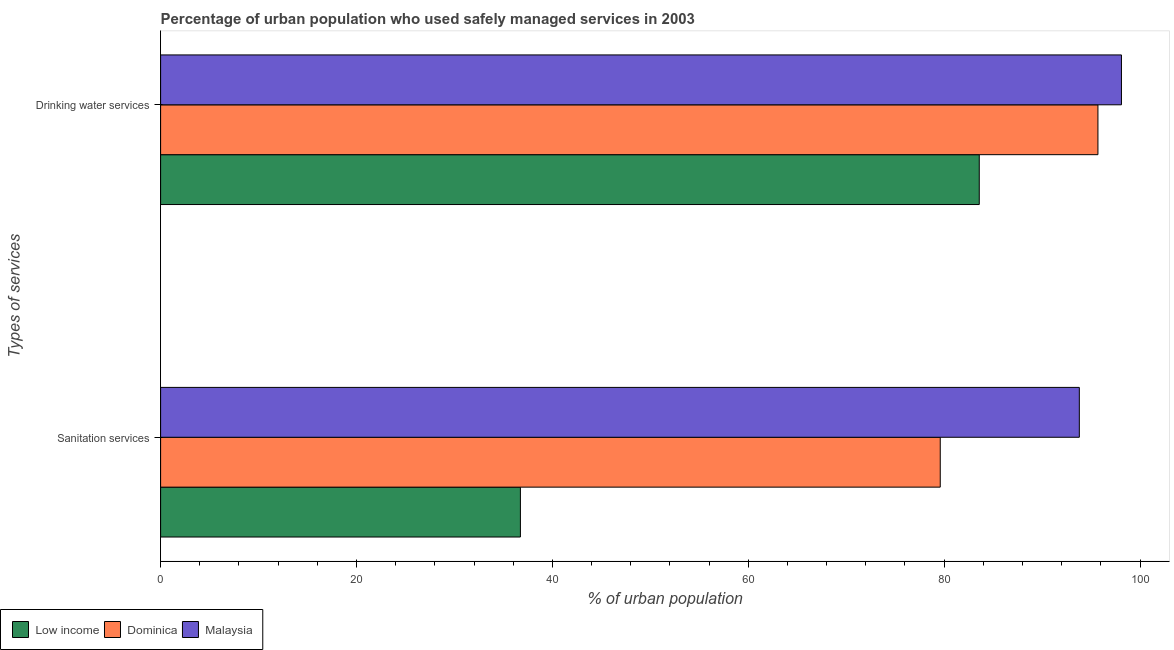How many different coloured bars are there?
Ensure brevity in your answer.  3. How many groups of bars are there?
Your answer should be very brief. 2. How many bars are there on the 2nd tick from the top?
Your response must be concise. 3. How many bars are there on the 1st tick from the bottom?
Provide a short and direct response. 3. What is the label of the 1st group of bars from the top?
Provide a short and direct response. Drinking water services. What is the percentage of urban population who used sanitation services in Malaysia?
Keep it short and to the point. 93.8. Across all countries, what is the maximum percentage of urban population who used drinking water services?
Give a very brief answer. 98.1. Across all countries, what is the minimum percentage of urban population who used drinking water services?
Provide a succinct answer. 83.58. In which country was the percentage of urban population who used sanitation services maximum?
Keep it short and to the point. Malaysia. In which country was the percentage of urban population who used sanitation services minimum?
Your answer should be very brief. Low income. What is the total percentage of urban population who used sanitation services in the graph?
Your response must be concise. 210.13. What is the difference between the percentage of urban population who used drinking water services in Low income and that in Malaysia?
Provide a short and direct response. -14.52. What is the difference between the percentage of urban population who used drinking water services in Low income and the percentage of urban population who used sanitation services in Malaysia?
Provide a short and direct response. -10.22. What is the average percentage of urban population who used sanitation services per country?
Ensure brevity in your answer.  70.04. What is the difference between the percentage of urban population who used sanitation services and percentage of urban population who used drinking water services in Low income?
Offer a very short reply. -46.85. In how many countries, is the percentage of urban population who used sanitation services greater than 48 %?
Offer a terse response. 2. What is the ratio of the percentage of urban population who used drinking water services in Malaysia to that in Low income?
Offer a terse response. 1.17. Is the percentage of urban population who used drinking water services in Low income less than that in Dominica?
Your answer should be very brief. Yes. What does the 3rd bar from the top in Drinking water services represents?
Provide a short and direct response. Low income. What does the 3rd bar from the bottom in Drinking water services represents?
Your response must be concise. Malaysia. Are all the bars in the graph horizontal?
Ensure brevity in your answer.  Yes. How many countries are there in the graph?
Your answer should be very brief. 3. What is the difference between two consecutive major ticks on the X-axis?
Your answer should be very brief. 20. How many legend labels are there?
Give a very brief answer. 3. What is the title of the graph?
Provide a succinct answer. Percentage of urban population who used safely managed services in 2003. Does "Guyana" appear as one of the legend labels in the graph?
Your answer should be very brief. No. What is the label or title of the X-axis?
Offer a very short reply. % of urban population. What is the label or title of the Y-axis?
Keep it short and to the point. Types of services. What is the % of urban population in Low income in Sanitation services?
Offer a very short reply. 36.73. What is the % of urban population of Dominica in Sanitation services?
Offer a very short reply. 79.6. What is the % of urban population of Malaysia in Sanitation services?
Offer a terse response. 93.8. What is the % of urban population in Low income in Drinking water services?
Give a very brief answer. 83.58. What is the % of urban population of Dominica in Drinking water services?
Provide a short and direct response. 95.7. What is the % of urban population in Malaysia in Drinking water services?
Provide a short and direct response. 98.1. Across all Types of services, what is the maximum % of urban population of Low income?
Your answer should be very brief. 83.58. Across all Types of services, what is the maximum % of urban population in Dominica?
Make the answer very short. 95.7. Across all Types of services, what is the maximum % of urban population of Malaysia?
Provide a succinct answer. 98.1. Across all Types of services, what is the minimum % of urban population of Low income?
Provide a short and direct response. 36.73. Across all Types of services, what is the minimum % of urban population of Dominica?
Offer a very short reply. 79.6. Across all Types of services, what is the minimum % of urban population in Malaysia?
Provide a short and direct response. 93.8. What is the total % of urban population of Low income in the graph?
Give a very brief answer. 120.32. What is the total % of urban population in Dominica in the graph?
Make the answer very short. 175.3. What is the total % of urban population in Malaysia in the graph?
Offer a very short reply. 191.9. What is the difference between the % of urban population of Low income in Sanitation services and that in Drinking water services?
Provide a short and direct response. -46.85. What is the difference between the % of urban population in Dominica in Sanitation services and that in Drinking water services?
Provide a succinct answer. -16.1. What is the difference between the % of urban population in Malaysia in Sanitation services and that in Drinking water services?
Provide a succinct answer. -4.3. What is the difference between the % of urban population of Low income in Sanitation services and the % of urban population of Dominica in Drinking water services?
Give a very brief answer. -58.97. What is the difference between the % of urban population in Low income in Sanitation services and the % of urban population in Malaysia in Drinking water services?
Provide a short and direct response. -61.37. What is the difference between the % of urban population of Dominica in Sanitation services and the % of urban population of Malaysia in Drinking water services?
Provide a succinct answer. -18.5. What is the average % of urban population in Low income per Types of services?
Keep it short and to the point. 60.16. What is the average % of urban population of Dominica per Types of services?
Offer a terse response. 87.65. What is the average % of urban population in Malaysia per Types of services?
Ensure brevity in your answer.  95.95. What is the difference between the % of urban population in Low income and % of urban population in Dominica in Sanitation services?
Offer a terse response. -42.87. What is the difference between the % of urban population in Low income and % of urban population in Malaysia in Sanitation services?
Your answer should be compact. -57.07. What is the difference between the % of urban population in Dominica and % of urban population in Malaysia in Sanitation services?
Offer a very short reply. -14.2. What is the difference between the % of urban population in Low income and % of urban population in Dominica in Drinking water services?
Make the answer very short. -12.12. What is the difference between the % of urban population of Low income and % of urban population of Malaysia in Drinking water services?
Your answer should be compact. -14.52. What is the ratio of the % of urban population in Low income in Sanitation services to that in Drinking water services?
Offer a very short reply. 0.44. What is the ratio of the % of urban population in Dominica in Sanitation services to that in Drinking water services?
Offer a terse response. 0.83. What is the ratio of the % of urban population in Malaysia in Sanitation services to that in Drinking water services?
Ensure brevity in your answer.  0.96. What is the difference between the highest and the second highest % of urban population of Low income?
Offer a terse response. 46.85. What is the difference between the highest and the second highest % of urban population in Dominica?
Offer a terse response. 16.1. What is the difference between the highest and the second highest % of urban population in Malaysia?
Ensure brevity in your answer.  4.3. What is the difference between the highest and the lowest % of urban population in Low income?
Your response must be concise. 46.85. What is the difference between the highest and the lowest % of urban population in Dominica?
Your answer should be compact. 16.1. 